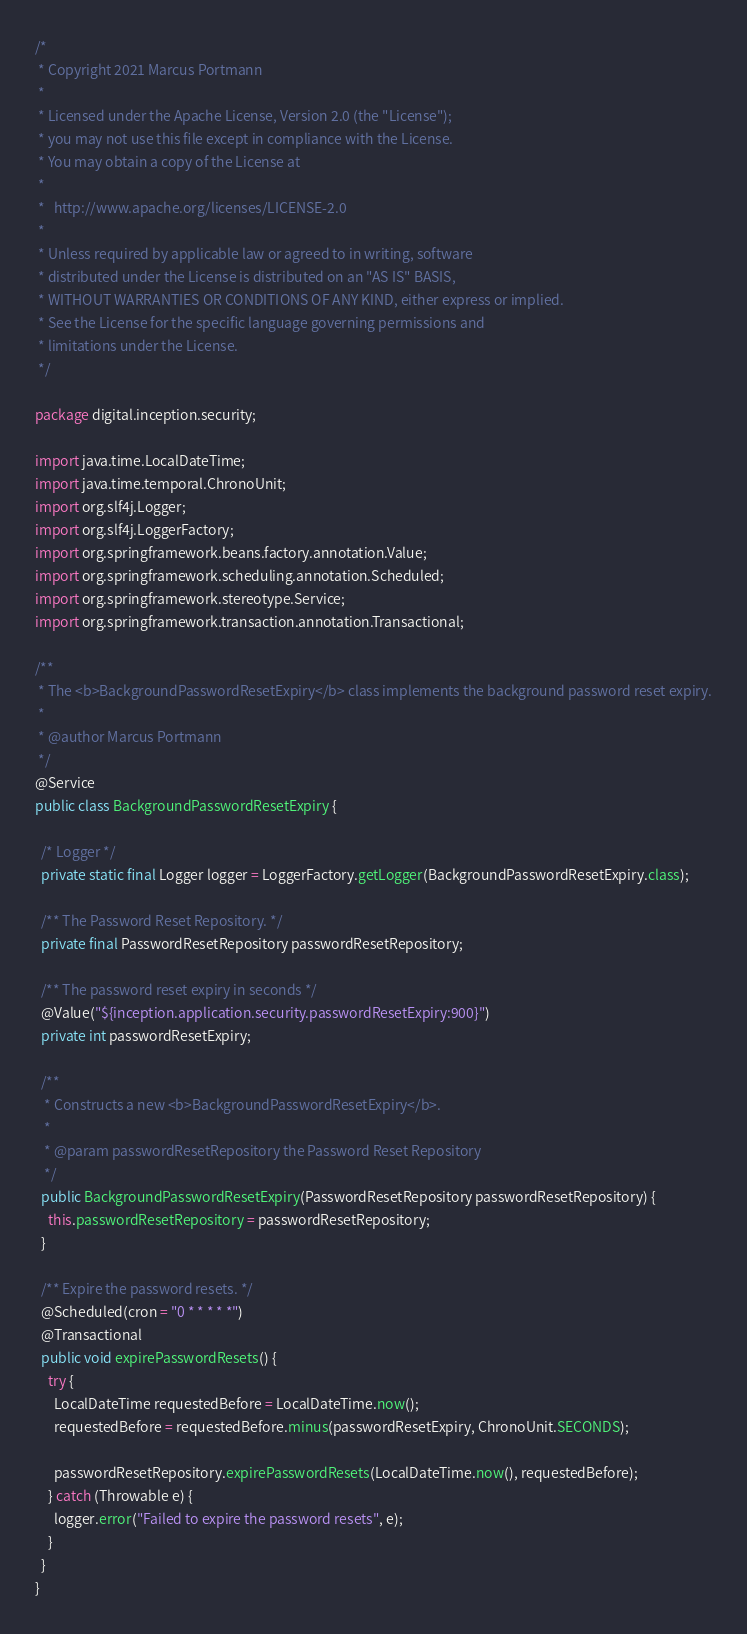Convert code to text. <code><loc_0><loc_0><loc_500><loc_500><_Java_>/*
 * Copyright 2021 Marcus Portmann
 *
 * Licensed under the Apache License, Version 2.0 (the "License");
 * you may not use this file except in compliance with the License.
 * You may obtain a copy of the License at
 *
 *   http://www.apache.org/licenses/LICENSE-2.0
 *
 * Unless required by applicable law or agreed to in writing, software
 * distributed under the License is distributed on an "AS IS" BASIS,
 * WITHOUT WARRANTIES OR CONDITIONS OF ANY KIND, either express or implied.
 * See the License for the specific language governing permissions and
 * limitations under the License.
 */

package digital.inception.security;

import java.time.LocalDateTime;
import java.time.temporal.ChronoUnit;
import org.slf4j.Logger;
import org.slf4j.LoggerFactory;
import org.springframework.beans.factory.annotation.Value;
import org.springframework.scheduling.annotation.Scheduled;
import org.springframework.stereotype.Service;
import org.springframework.transaction.annotation.Transactional;

/**
 * The <b>BackgroundPasswordResetExpiry</b> class implements the background password reset expiry.
 *
 * @author Marcus Portmann
 */
@Service
public class BackgroundPasswordResetExpiry {

  /* Logger */
  private static final Logger logger = LoggerFactory.getLogger(BackgroundPasswordResetExpiry.class);

  /** The Password Reset Repository. */
  private final PasswordResetRepository passwordResetRepository;

  /** The password reset expiry in seconds */
  @Value("${inception.application.security.passwordResetExpiry:900}")
  private int passwordResetExpiry;

  /**
   * Constructs a new <b>BackgroundPasswordResetExpiry</b>.
   *
   * @param passwordResetRepository the Password Reset Repository
   */
  public BackgroundPasswordResetExpiry(PasswordResetRepository passwordResetRepository) {
    this.passwordResetRepository = passwordResetRepository;
  }

  /** Expire the password resets. */
  @Scheduled(cron = "0 * * * * *")
  @Transactional
  public void expirePasswordResets() {
    try {
      LocalDateTime requestedBefore = LocalDateTime.now();
      requestedBefore = requestedBefore.minus(passwordResetExpiry, ChronoUnit.SECONDS);

      passwordResetRepository.expirePasswordResets(LocalDateTime.now(), requestedBefore);
    } catch (Throwable e) {
      logger.error("Failed to expire the password resets", e);
    }
  }
}
</code> 